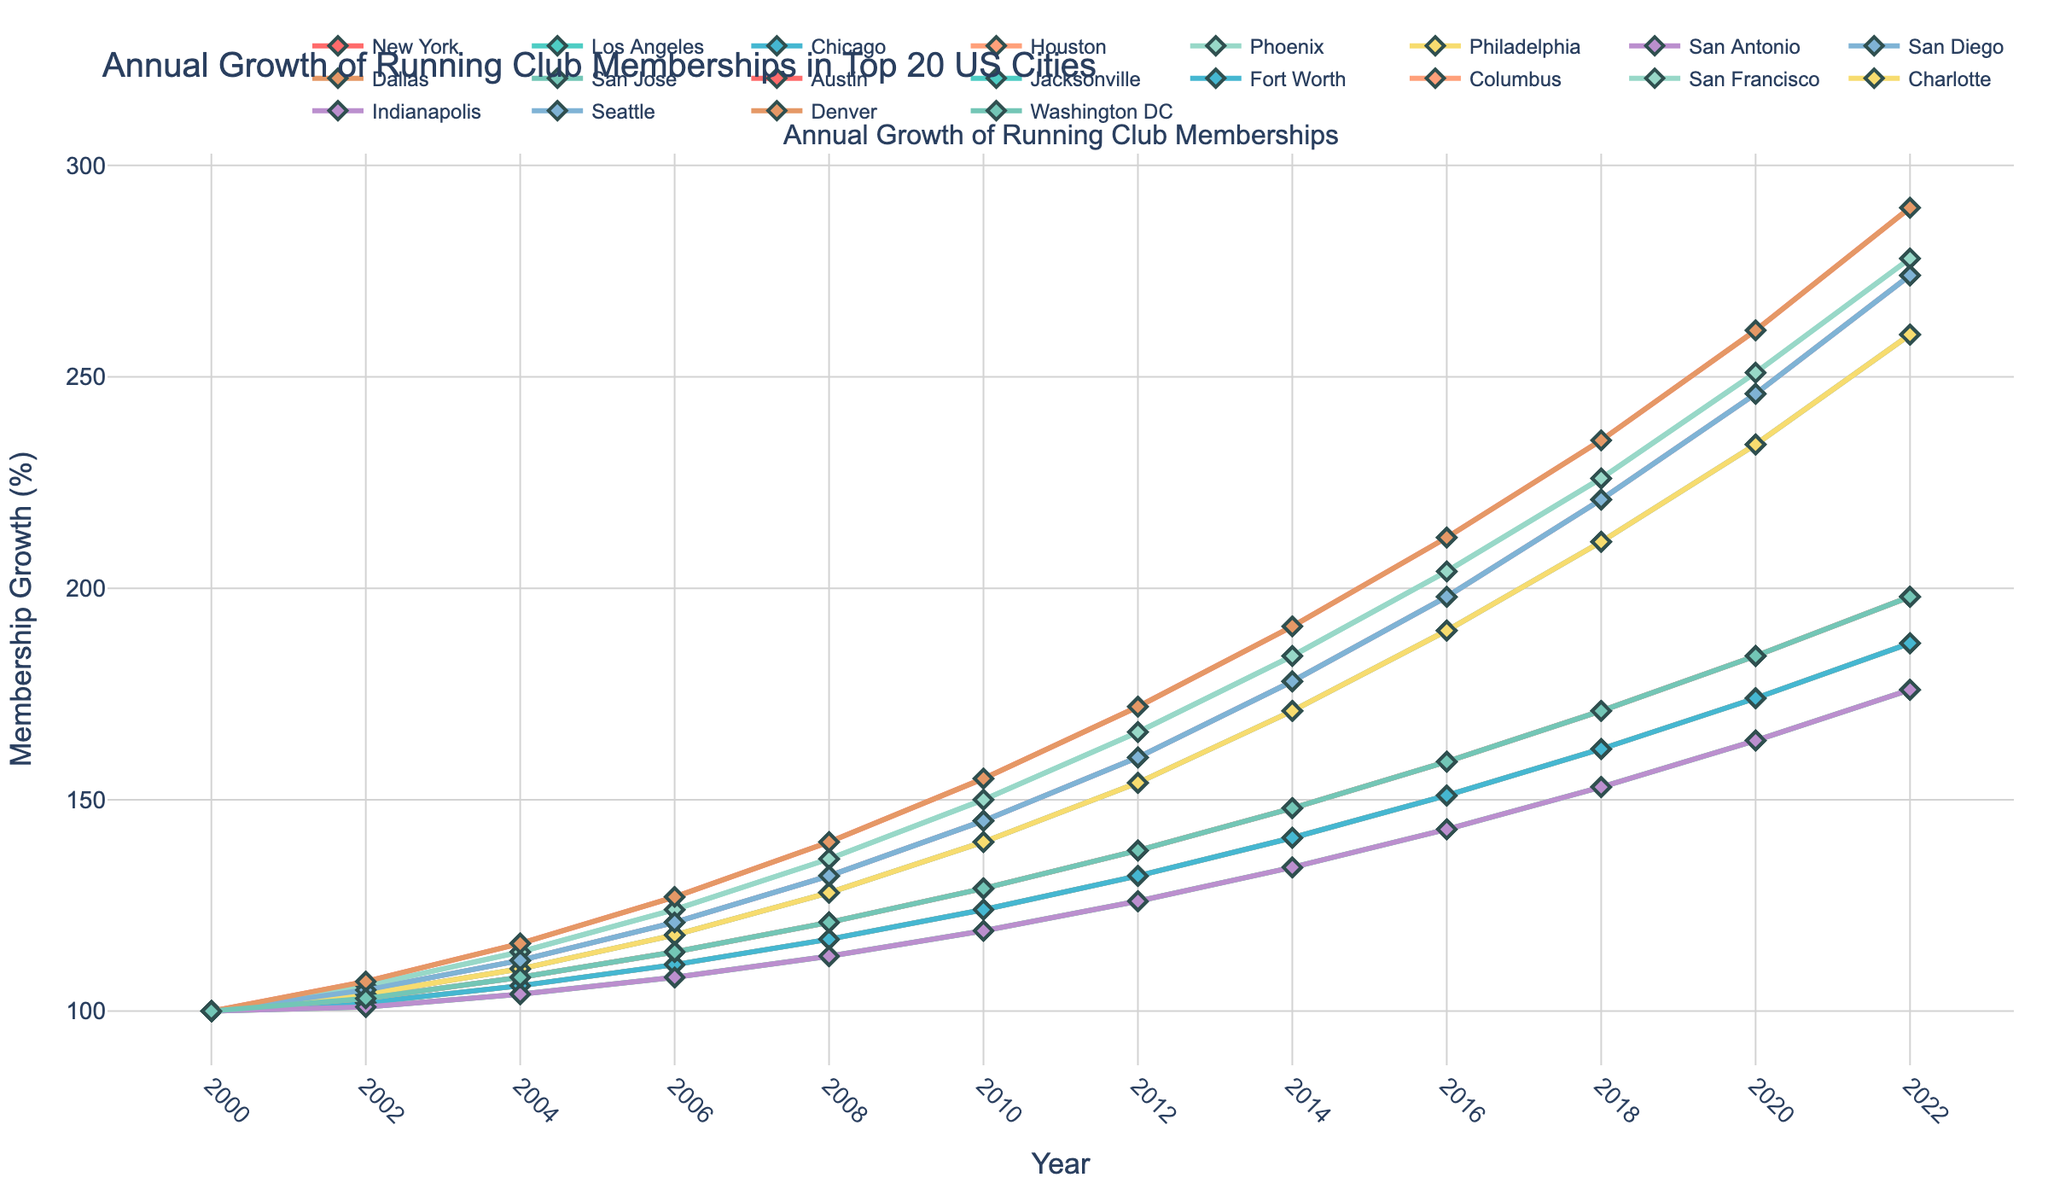Which city experienced the greatest membership growth between 2000 and 2022? To determine which city had the greatest membership growth, we need to look at the final values for each city in 2022 and compare them to the baseline in 2000. "Phoenix" grew from 100 to 278, showing significant growth among all.
Answer: Phoenix What is the difference in the membership growth between Houston and Phoenix in 2008? In 2008, Houston's membership growth was 128%, and Phoenix's was 136%. The difference between them is 136% - 128% = 8%.
Answer: 8% Which city had the least membership growth in 2012? We look at the values for all cities in 2012 and identify the lowest one. Philadelphia had the least growth with a value of 126%.
Answer: Philadelphia How much did the membership grow on average across all cities in 2020? First, sum up the 2020 values for all cities and then divide by the number of cities (20). The sum is 4168, therefore the average is 4168/20 = 208.4%.
Answer: 208.4% Did any city’s membership growth surpass 250% before 2020? To answer this, we check each city's membership growth year by year up to but not including 2020 to see if any exceed 250%. No city's growth surpassed 250% before 2020.
Answer: No Which city's membership growth was consistently higher than 130% after 2008? We need to check each year for the values, and we see "Phoenix" consistently had membership growth higher than 130% every year after 2008.
Answer: Phoenix What is the average growth rate in 2022 for San Francisco, Indianapolis, and Denver combined? The 2022 values for these cities are 278%, 198%, and 290%. The sum of these values is 766%, divided by 3 gives an average of 255.3%.
Answer: 255.3% During which year did Washington DC overtake the membership growth of San Antonio? We compare Washington DC and San Antonio year by year; in 2018, Washington DC (235%) overtakes San Antonio (171%).
Answer: 2018 Which cities had a membership growth close to 200% in 2016? Looking at the 2016 values, New York (198%), San Diego (198%), and Washington DC (212%) are the closest to 200%.
Answer: New York, San Diego, Washington DC Was there any year where Los Angeles had greater membership growth compared to New York? We compare the values of Los Angeles and New York year by year; Los Angeles never had a greater membership growth than New York in any given year.
Answer: No 